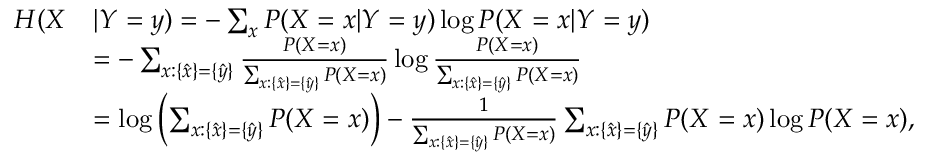Convert formula to latex. <formula><loc_0><loc_0><loc_500><loc_500>\begin{array} { r l } { H ( X } & { | Y = y ) = - \sum _ { x } P ( X = x | Y = y ) \log P ( X = x | Y = y ) } \\ & { = - \sum _ { x \colon \{ \hat { x } \} = \{ \hat { y } \} } \frac { P ( X = x ) } { \sum _ { x \colon \{ \hat { x } \} = \{ \hat { y } \} } P ( X = x ) } \log \frac { P ( X = x ) } { \sum _ { x \colon \{ \hat { x } \} = \{ \hat { y } \} } P ( X = x ) } } \\ & { = \log \left ( \sum _ { x \colon \{ \hat { x } \} = \{ \hat { y } \} } P ( X = x ) \right ) - \frac { 1 } { \sum _ { x \colon \{ \hat { x } \} = \{ \hat { y } \} } P ( X = x ) } \sum _ { x \colon \{ \hat { x } \} = \{ \hat { y } \} } P ( X = x ) \log P ( X = x ) , } \end{array}</formula> 